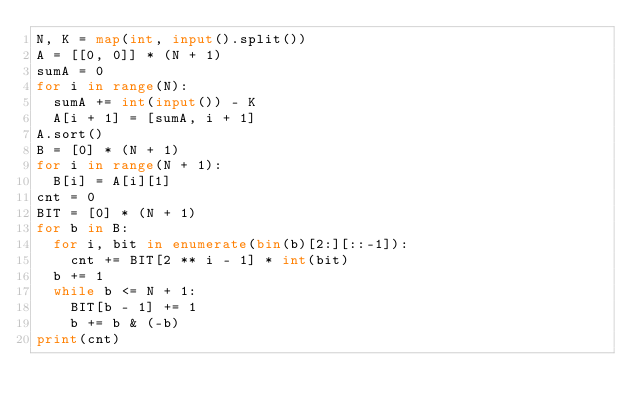Convert code to text. <code><loc_0><loc_0><loc_500><loc_500><_Python_>N, K = map(int, input().split())
A = [[0, 0]] * (N + 1)
sumA = 0
for i in range(N):
  sumA += int(input()) - K
  A[i + 1] = [sumA, i + 1]
A.sort()
B = [0] * (N + 1)
for i in range(N + 1):
  B[i] = A[i][1]
cnt = 0
BIT = [0] * (N + 1)
for b in B:
  for i, bit in enumerate(bin(b)[2:][::-1]):
    cnt += BIT[2 ** i - 1] * int(bit)
  b += 1
  while b <= N + 1:
    BIT[b - 1] += 1
    b += b & (-b)
print(cnt)</code> 